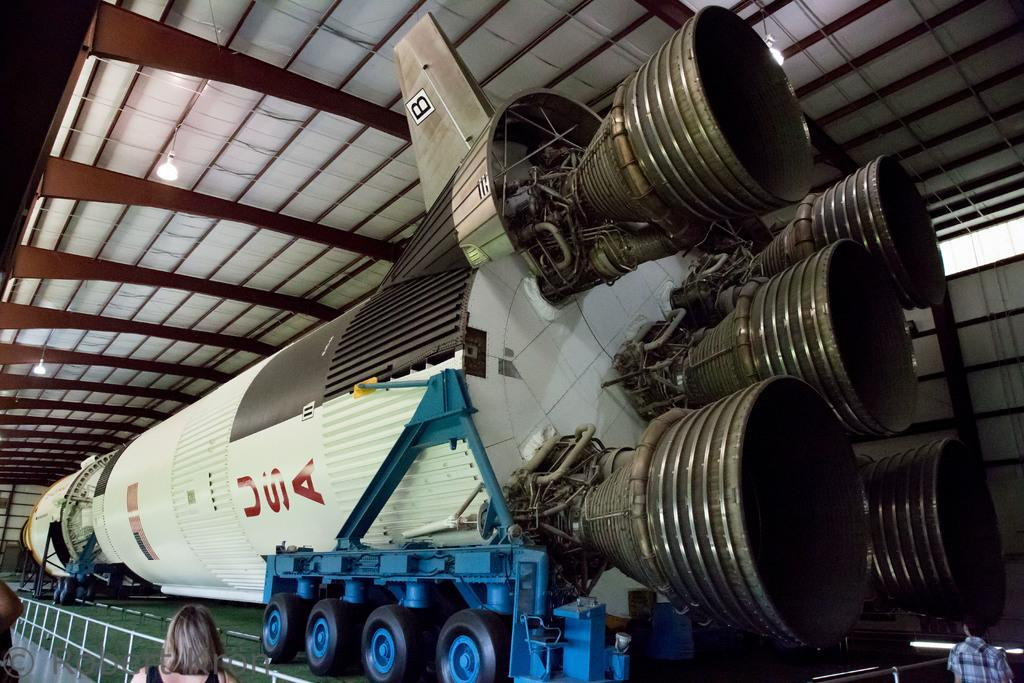<image>
Relay a brief, clear account of the picture shown. A USA space shuttle that has 4 blasters on it 